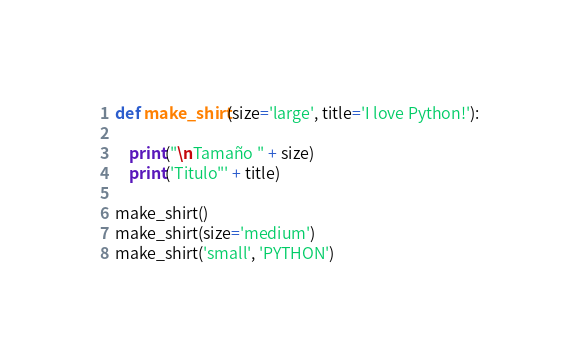<code> <loc_0><loc_0><loc_500><loc_500><_Python_>def make_shirt(size='large', title='I love Python!'):
    
    print("\nTamaño " + size)
    print('Titulo"' + title)

make_shirt()
make_shirt(size='medium')
make_shirt('small', 'PYTHON')



</code> 